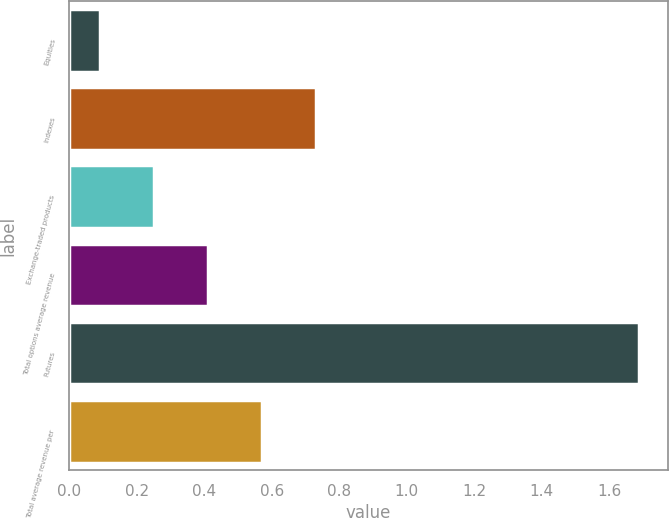<chart> <loc_0><loc_0><loc_500><loc_500><bar_chart><fcel>Equities<fcel>Indexes<fcel>Exchange-traded products<fcel>Total options average revenue<fcel>Futures<fcel>Total average revenue per<nl><fcel>0.09<fcel>0.73<fcel>0.25<fcel>0.41<fcel>1.69<fcel>0.57<nl></chart> 